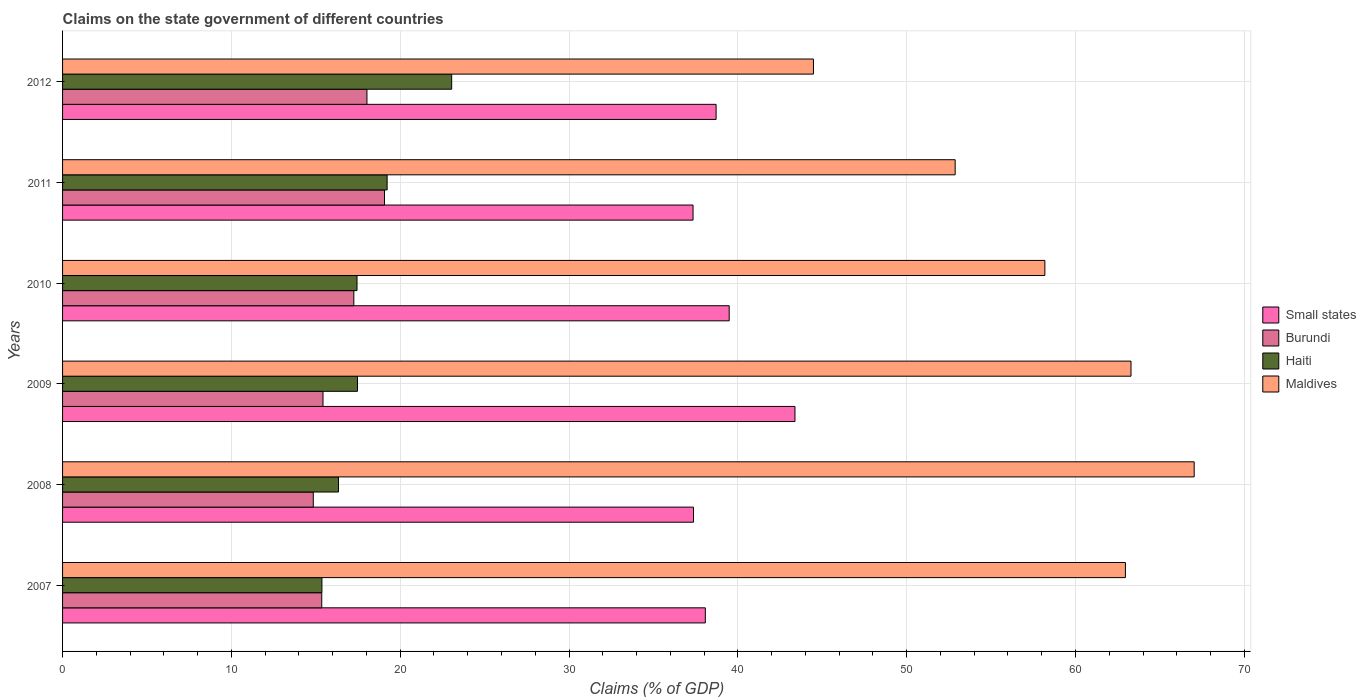How many groups of bars are there?
Provide a short and direct response. 6. Are the number of bars per tick equal to the number of legend labels?
Your response must be concise. Yes. Are the number of bars on each tick of the Y-axis equal?
Provide a succinct answer. Yes. How many bars are there on the 4th tick from the top?
Give a very brief answer. 4. What is the label of the 2nd group of bars from the top?
Give a very brief answer. 2011. In how many cases, is the number of bars for a given year not equal to the number of legend labels?
Make the answer very short. 0. What is the percentage of GDP claimed on the state government in Burundi in 2010?
Offer a very short reply. 17.25. Across all years, what is the maximum percentage of GDP claimed on the state government in Haiti?
Offer a terse response. 23.05. Across all years, what is the minimum percentage of GDP claimed on the state government in Small states?
Keep it short and to the point. 37.35. In which year was the percentage of GDP claimed on the state government in Burundi maximum?
Your answer should be compact. 2011. In which year was the percentage of GDP claimed on the state government in Haiti minimum?
Offer a terse response. 2007. What is the total percentage of GDP claimed on the state government in Burundi in the graph?
Your answer should be very brief. 99.98. What is the difference between the percentage of GDP claimed on the state government in Maldives in 2009 and that in 2012?
Your response must be concise. 18.81. What is the difference between the percentage of GDP claimed on the state government in Small states in 2009 and the percentage of GDP claimed on the state government in Burundi in 2012?
Your answer should be compact. 25.35. What is the average percentage of GDP claimed on the state government in Haiti per year?
Your answer should be very brief. 18.15. In the year 2010, what is the difference between the percentage of GDP claimed on the state government in Burundi and percentage of GDP claimed on the state government in Small states?
Provide a short and direct response. -22.24. What is the ratio of the percentage of GDP claimed on the state government in Haiti in 2008 to that in 2012?
Make the answer very short. 0.71. Is the difference between the percentage of GDP claimed on the state government in Burundi in 2007 and 2009 greater than the difference between the percentage of GDP claimed on the state government in Small states in 2007 and 2009?
Offer a very short reply. Yes. What is the difference between the highest and the second highest percentage of GDP claimed on the state government in Maldives?
Your answer should be compact. 3.74. What is the difference between the highest and the lowest percentage of GDP claimed on the state government in Maldives?
Offer a very short reply. 22.55. Is the sum of the percentage of GDP claimed on the state government in Maldives in 2007 and 2010 greater than the maximum percentage of GDP claimed on the state government in Haiti across all years?
Offer a very short reply. Yes. What does the 4th bar from the top in 2007 represents?
Offer a terse response. Small states. What does the 1st bar from the bottom in 2009 represents?
Offer a terse response. Small states. Are all the bars in the graph horizontal?
Provide a short and direct response. Yes. How many years are there in the graph?
Offer a terse response. 6. Are the values on the major ticks of X-axis written in scientific E-notation?
Offer a terse response. No. Does the graph contain any zero values?
Keep it short and to the point. No. Does the graph contain grids?
Offer a very short reply. Yes. Where does the legend appear in the graph?
Your answer should be very brief. Center right. How many legend labels are there?
Your answer should be compact. 4. What is the title of the graph?
Give a very brief answer. Claims on the state government of different countries. Does "Arab World" appear as one of the legend labels in the graph?
Give a very brief answer. No. What is the label or title of the X-axis?
Provide a succinct answer. Claims (% of GDP). What is the label or title of the Y-axis?
Provide a short and direct response. Years. What is the Claims (% of GDP) in Small states in 2007?
Your response must be concise. 38.07. What is the Claims (% of GDP) of Burundi in 2007?
Give a very brief answer. 15.35. What is the Claims (% of GDP) of Haiti in 2007?
Ensure brevity in your answer.  15.36. What is the Claims (% of GDP) of Maldives in 2007?
Ensure brevity in your answer.  62.96. What is the Claims (% of GDP) in Small states in 2008?
Ensure brevity in your answer.  37.37. What is the Claims (% of GDP) in Burundi in 2008?
Your answer should be compact. 14.85. What is the Claims (% of GDP) in Haiti in 2008?
Your response must be concise. 16.34. What is the Claims (% of GDP) in Maldives in 2008?
Provide a short and direct response. 67.03. What is the Claims (% of GDP) in Small states in 2009?
Provide a succinct answer. 43.38. What is the Claims (% of GDP) of Burundi in 2009?
Provide a succinct answer. 15.43. What is the Claims (% of GDP) in Haiti in 2009?
Your answer should be compact. 17.47. What is the Claims (% of GDP) in Maldives in 2009?
Make the answer very short. 63.29. What is the Claims (% of GDP) of Small states in 2010?
Provide a short and direct response. 39.49. What is the Claims (% of GDP) of Burundi in 2010?
Provide a succinct answer. 17.25. What is the Claims (% of GDP) in Haiti in 2010?
Ensure brevity in your answer.  17.44. What is the Claims (% of GDP) in Maldives in 2010?
Provide a short and direct response. 58.19. What is the Claims (% of GDP) of Small states in 2011?
Keep it short and to the point. 37.35. What is the Claims (% of GDP) of Burundi in 2011?
Your response must be concise. 19.07. What is the Claims (% of GDP) of Haiti in 2011?
Offer a very short reply. 19.23. What is the Claims (% of GDP) of Maldives in 2011?
Offer a very short reply. 52.87. What is the Claims (% of GDP) of Small states in 2012?
Your answer should be compact. 38.71. What is the Claims (% of GDP) in Burundi in 2012?
Your answer should be compact. 18.03. What is the Claims (% of GDP) in Haiti in 2012?
Keep it short and to the point. 23.05. What is the Claims (% of GDP) of Maldives in 2012?
Give a very brief answer. 44.48. Across all years, what is the maximum Claims (% of GDP) in Small states?
Provide a short and direct response. 43.38. Across all years, what is the maximum Claims (% of GDP) of Burundi?
Your answer should be compact. 19.07. Across all years, what is the maximum Claims (% of GDP) of Haiti?
Offer a very short reply. 23.05. Across all years, what is the maximum Claims (% of GDP) of Maldives?
Provide a succinct answer. 67.03. Across all years, what is the minimum Claims (% of GDP) in Small states?
Ensure brevity in your answer.  37.35. Across all years, what is the minimum Claims (% of GDP) in Burundi?
Offer a very short reply. 14.85. Across all years, what is the minimum Claims (% of GDP) in Haiti?
Ensure brevity in your answer.  15.36. Across all years, what is the minimum Claims (% of GDP) in Maldives?
Give a very brief answer. 44.48. What is the total Claims (% of GDP) in Small states in the graph?
Make the answer very short. 234.38. What is the total Claims (% of GDP) of Burundi in the graph?
Ensure brevity in your answer.  99.98. What is the total Claims (% of GDP) in Haiti in the graph?
Provide a succinct answer. 108.89. What is the total Claims (% of GDP) of Maldives in the graph?
Your response must be concise. 348.82. What is the difference between the Claims (% of GDP) in Small states in 2007 and that in 2008?
Offer a very short reply. 0.7. What is the difference between the Claims (% of GDP) of Burundi in 2007 and that in 2008?
Offer a terse response. 0.5. What is the difference between the Claims (% of GDP) of Haiti in 2007 and that in 2008?
Offer a very short reply. -0.98. What is the difference between the Claims (% of GDP) of Maldives in 2007 and that in 2008?
Provide a succinct answer. -4.07. What is the difference between the Claims (% of GDP) in Small states in 2007 and that in 2009?
Ensure brevity in your answer.  -5.31. What is the difference between the Claims (% of GDP) in Burundi in 2007 and that in 2009?
Give a very brief answer. -0.07. What is the difference between the Claims (% of GDP) of Haiti in 2007 and that in 2009?
Offer a very short reply. -2.11. What is the difference between the Claims (% of GDP) in Maldives in 2007 and that in 2009?
Your answer should be very brief. -0.33. What is the difference between the Claims (% of GDP) of Small states in 2007 and that in 2010?
Offer a terse response. -1.41. What is the difference between the Claims (% of GDP) in Burundi in 2007 and that in 2010?
Your answer should be compact. -1.9. What is the difference between the Claims (% of GDP) of Haiti in 2007 and that in 2010?
Give a very brief answer. -2.08. What is the difference between the Claims (% of GDP) of Maldives in 2007 and that in 2010?
Your answer should be compact. 4.77. What is the difference between the Claims (% of GDP) in Small states in 2007 and that in 2011?
Give a very brief answer. 0.73. What is the difference between the Claims (% of GDP) in Burundi in 2007 and that in 2011?
Keep it short and to the point. -3.72. What is the difference between the Claims (% of GDP) of Haiti in 2007 and that in 2011?
Keep it short and to the point. -3.86. What is the difference between the Claims (% of GDP) of Maldives in 2007 and that in 2011?
Keep it short and to the point. 10.08. What is the difference between the Claims (% of GDP) of Small states in 2007 and that in 2012?
Offer a very short reply. -0.64. What is the difference between the Claims (% of GDP) in Burundi in 2007 and that in 2012?
Provide a short and direct response. -2.68. What is the difference between the Claims (% of GDP) in Haiti in 2007 and that in 2012?
Offer a terse response. -7.69. What is the difference between the Claims (% of GDP) in Maldives in 2007 and that in 2012?
Offer a terse response. 18.48. What is the difference between the Claims (% of GDP) in Small states in 2008 and that in 2009?
Provide a short and direct response. -6.01. What is the difference between the Claims (% of GDP) in Burundi in 2008 and that in 2009?
Offer a terse response. -0.58. What is the difference between the Claims (% of GDP) in Haiti in 2008 and that in 2009?
Offer a terse response. -1.13. What is the difference between the Claims (% of GDP) of Maldives in 2008 and that in 2009?
Your answer should be compact. 3.74. What is the difference between the Claims (% of GDP) of Small states in 2008 and that in 2010?
Your answer should be very brief. -2.12. What is the difference between the Claims (% of GDP) in Burundi in 2008 and that in 2010?
Your answer should be very brief. -2.4. What is the difference between the Claims (% of GDP) in Haiti in 2008 and that in 2010?
Ensure brevity in your answer.  -1.1. What is the difference between the Claims (% of GDP) of Maldives in 2008 and that in 2010?
Ensure brevity in your answer.  8.84. What is the difference between the Claims (% of GDP) of Small states in 2008 and that in 2011?
Your answer should be very brief. 0.03. What is the difference between the Claims (% of GDP) in Burundi in 2008 and that in 2011?
Keep it short and to the point. -4.22. What is the difference between the Claims (% of GDP) in Haiti in 2008 and that in 2011?
Provide a short and direct response. -2.88. What is the difference between the Claims (% of GDP) in Maldives in 2008 and that in 2011?
Keep it short and to the point. 14.16. What is the difference between the Claims (% of GDP) of Small states in 2008 and that in 2012?
Keep it short and to the point. -1.34. What is the difference between the Claims (% of GDP) in Burundi in 2008 and that in 2012?
Make the answer very short. -3.18. What is the difference between the Claims (% of GDP) in Haiti in 2008 and that in 2012?
Make the answer very short. -6.7. What is the difference between the Claims (% of GDP) in Maldives in 2008 and that in 2012?
Give a very brief answer. 22.55. What is the difference between the Claims (% of GDP) in Small states in 2009 and that in 2010?
Your response must be concise. 3.9. What is the difference between the Claims (% of GDP) of Burundi in 2009 and that in 2010?
Your answer should be very brief. -1.83. What is the difference between the Claims (% of GDP) in Haiti in 2009 and that in 2010?
Give a very brief answer. 0.03. What is the difference between the Claims (% of GDP) in Maldives in 2009 and that in 2010?
Provide a short and direct response. 5.1. What is the difference between the Claims (% of GDP) in Small states in 2009 and that in 2011?
Keep it short and to the point. 6.04. What is the difference between the Claims (% of GDP) of Burundi in 2009 and that in 2011?
Your answer should be compact. -3.64. What is the difference between the Claims (% of GDP) in Haiti in 2009 and that in 2011?
Your answer should be very brief. -1.76. What is the difference between the Claims (% of GDP) of Maldives in 2009 and that in 2011?
Your answer should be compact. 10.42. What is the difference between the Claims (% of GDP) of Small states in 2009 and that in 2012?
Offer a terse response. 4.67. What is the difference between the Claims (% of GDP) in Burundi in 2009 and that in 2012?
Offer a terse response. -2.6. What is the difference between the Claims (% of GDP) of Haiti in 2009 and that in 2012?
Offer a very short reply. -5.58. What is the difference between the Claims (% of GDP) in Maldives in 2009 and that in 2012?
Offer a very short reply. 18.81. What is the difference between the Claims (% of GDP) of Small states in 2010 and that in 2011?
Your answer should be very brief. 2.14. What is the difference between the Claims (% of GDP) of Burundi in 2010 and that in 2011?
Ensure brevity in your answer.  -1.82. What is the difference between the Claims (% of GDP) of Haiti in 2010 and that in 2011?
Provide a short and direct response. -1.78. What is the difference between the Claims (% of GDP) of Maldives in 2010 and that in 2011?
Ensure brevity in your answer.  5.31. What is the difference between the Claims (% of GDP) in Small states in 2010 and that in 2012?
Offer a terse response. 0.78. What is the difference between the Claims (% of GDP) of Burundi in 2010 and that in 2012?
Provide a short and direct response. -0.78. What is the difference between the Claims (% of GDP) in Haiti in 2010 and that in 2012?
Your answer should be very brief. -5.61. What is the difference between the Claims (% of GDP) of Maldives in 2010 and that in 2012?
Make the answer very short. 13.71. What is the difference between the Claims (% of GDP) of Small states in 2011 and that in 2012?
Make the answer very short. -1.37. What is the difference between the Claims (% of GDP) in Burundi in 2011 and that in 2012?
Offer a terse response. 1.04. What is the difference between the Claims (% of GDP) in Haiti in 2011 and that in 2012?
Give a very brief answer. -3.82. What is the difference between the Claims (% of GDP) of Maldives in 2011 and that in 2012?
Your answer should be very brief. 8.39. What is the difference between the Claims (% of GDP) of Small states in 2007 and the Claims (% of GDP) of Burundi in 2008?
Your answer should be very brief. 23.22. What is the difference between the Claims (% of GDP) of Small states in 2007 and the Claims (% of GDP) of Haiti in 2008?
Offer a terse response. 21.73. What is the difference between the Claims (% of GDP) in Small states in 2007 and the Claims (% of GDP) in Maldives in 2008?
Keep it short and to the point. -28.96. What is the difference between the Claims (% of GDP) in Burundi in 2007 and the Claims (% of GDP) in Haiti in 2008?
Offer a terse response. -0.99. What is the difference between the Claims (% of GDP) of Burundi in 2007 and the Claims (% of GDP) of Maldives in 2008?
Provide a short and direct response. -51.68. What is the difference between the Claims (% of GDP) in Haiti in 2007 and the Claims (% of GDP) in Maldives in 2008?
Make the answer very short. -51.67. What is the difference between the Claims (% of GDP) in Small states in 2007 and the Claims (% of GDP) in Burundi in 2009?
Give a very brief answer. 22.65. What is the difference between the Claims (% of GDP) in Small states in 2007 and the Claims (% of GDP) in Haiti in 2009?
Your answer should be compact. 20.6. What is the difference between the Claims (% of GDP) of Small states in 2007 and the Claims (% of GDP) of Maldives in 2009?
Provide a succinct answer. -25.22. What is the difference between the Claims (% of GDP) of Burundi in 2007 and the Claims (% of GDP) of Haiti in 2009?
Ensure brevity in your answer.  -2.12. What is the difference between the Claims (% of GDP) of Burundi in 2007 and the Claims (% of GDP) of Maldives in 2009?
Offer a terse response. -47.94. What is the difference between the Claims (% of GDP) of Haiti in 2007 and the Claims (% of GDP) of Maldives in 2009?
Offer a very short reply. -47.93. What is the difference between the Claims (% of GDP) of Small states in 2007 and the Claims (% of GDP) of Burundi in 2010?
Provide a succinct answer. 20.82. What is the difference between the Claims (% of GDP) of Small states in 2007 and the Claims (% of GDP) of Haiti in 2010?
Make the answer very short. 20.63. What is the difference between the Claims (% of GDP) of Small states in 2007 and the Claims (% of GDP) of Maldives in 2010?
Provide a short and direct response. -20.11. What is the difference between the Claims (% of GDP) in Burundi in 2007 and the Claims (% of GDP) in Haiti in 2010?
Your response must be concise. -2.09. What is the difference between the Claims (% of GDP) of Burundi in 2007 and the Claims (% of GDP) of Maldives in 2010?
Make the answer very short. -42.83. What is the difference between the Claims (% of GDP) of Haiti in 2007 and the Claims (% of GDP) of Maldives in 2010?
Offer a terse response. -42.82. What is the difference between the Claims (% of GDP) of Small states in 2007 and the Claims (% of GDP) of Burundi in 2011?
Give a very brief answer. 19. What is the difference between the Claims (% of GDP) in Small states in 2007 and the Claims (% of GDP) in Haiti in 2011?
Your answer should be very brief. 18.85. What is the difference between the Claims (% of GDP) in Small states in 2007 and the Claims (% of GDP) in Maldives in 2011?
Your answer should be compact. -14.8. What is the difference between the Claims (% of GDP) in Burundi in 2007 and the Claims (% of GDP) in Haiti in 2011?
Your response must be concise. -3.87. What is the difference between the Claims (% of GDP) in Burundi in 2007 and the Claims (% of GDP) in Maldives in 2011?
Your response must be concise. -37.52. What is the difference between the Claims (% of GDP) in Haiti in 2007 and the Claims (% of GDP) in Maldives in 2011?
Keep it short and to the point. -37.51. What is the difference between the Claims (% of GDP) in Small states in 2007 and the Claims (% of GDP) in Burundi in 2012?
Your answer should be compact. 20.04. What is the difference between the Claims (% of GDP) of Small states in 2007 and the Claims (% of GDP) of Haiti in 2012?
Provide a short and direct response. 15.03. What is the difference between the Claims (% of GDP) of Small states in 2007 and the Claims (% of GDP) of Maldives in 2012?
Your answer should be compact. -6.41. What is the difference between the Claims (% of GDP) of Burundi in 2007 and the Claims (% of GDP) of Haiti in 2012?
Your answer should be very brief. -7.7. What is the difference between the Claims (% of GDP) of Burundi in 2007 and the Claims (% of GDP) of Maldives in 2012?
Provide a succinct answer. -29.13. What is the difference between the Claims (% of GDP) of Haiti in 2007 and the Claims (% of GDP) of Maldives in 2012?
Give a very brief answer. -29.12. What is the difference between the Claims (% of GDP) in Small states in 2008 and the Claims (% of GDP) in Burundi in 2009?
Offer a very short reply. 21.95. What is the difference between the Claims (% of GDP) of Small states in 2008 and the Claims (% of GDP) of Haiti in 2009?
Offer a terse response. 19.9. What is the difference between the Claims (% of GDP) in Small states in 2008 and the Claims (% of GDP) in Maldives in 2009?
Your answer should be compact. -25.92. What is the difference between the Claims (% of GDP) of Burundi in 2008 and the Claims (% of GDP) of Haiti in 2009?
Ensure brevity in your answer.  -2.62. What is the difference between the Claims (% of GDP) of Burundi in 2008 and the Claims (% of GDP) of Maldives in 2009?
Provide a short and direct response. -48.44. What is the difference between the Claims (% of GDP) in Haiti in 2008 and the Claims (% of GDP) in Maldives in 2009?
Your answer should be very brief. -46.94. What is the difference between the Claims (% of GDP) in Small states in 2008 and the Claims (% of GDP) in Burundi in 2010?
Your answer should be very brief. 20.12. What is the difference between the Claims (% of GDP) in Small states in 2008 and the Claims (% of GDP) in Haiti in 2010?
Give a very brief answer. 19.93. What is the difference between the Claims (% of GDP) of Small states in 2008 and the Claims (% of GDP) of Maldives in 2010?
Give a very brief answer. -20.81. What is the difference between the Claims (% of GDP) of Burundi in 2008 and the Claims (% of GDP) of Haiti in 2010?
Your answer should be very brief. -2.59. What is the difference between the Claims (% of GDP) in Burundi in 2008 and the Claims (% of GDP) in Maldives in 2010?
Provide a succinct answer. -43.34. What is the difference between the Claims (% of GDP) in Haiti in 2008 and the Claims (% of GDP) in Maldives in 2010?
Your answer should be compact. -41.84. What is the difference between the Claims (% of GDP) of Small states in 2008 and the Claims (% of GDP) of Burundi in 2011?
Keep it short and to the point. 18.3. What is the difference between the Claims (% of GDP) in Small states in 2008 and the Claims (% of GDP) in Haiti in 2011?
Provide a succinct answer. 18.15. What is the difference between the Claims (% of GDP) of Small states in 2008 and the Claims (% of GDP) of Maldives in 2011?
Your answer should be compact. -15.5. What is the difference between the Claims (% of GDP) in Burundi in 2008 and the Claims (% of GDP) in Haiti in 2011?
Make the answer very short. -4.37. What is the difference between the Claims (% of GDP) of Burundi in 2008 and the Claims (% of GDP) of Maldives in 2011?
Offer a very short reply. -38.02. What is the difference between the Claims (% of GDP) of Haiti in 2008 and the Claims (% of GDP) of Maldives in 2011?
Your answer should be very brief. -36.53. What is the difference between the Claims (% of GDP) of Small states in 2008 and the Claims (% of GDP) of Burundi in 2012?
Provide a short and direct response. 19.34. What is the difference between the Claims (% of GDP) in Small states in 2008 and the Claims (% of GDP) in Haiti in 2012?
Make the answer very short. 14.32. What is the difference between the Claims (% of GDP) in Small states in 2008 and the Claims (% of GDP) in Maldives in 2012?
Your answer should be compact. -7.11. What is the difference between the Claims (% of GDP) in Burundi in 2008 and the Claims (% of GDP) in Haiti in 2012?
Offer a very short reply. -8.2. What is the difference between the Claims (% of GDP) in Burundi in 2008 and the Claims (% of GDP) in Maldives in 2012?
Give a very brief answer. -29.63. What is the difference between the Claims (% of GDP) of Haiti in 2008 and the Claims (% of GDP) of Maldives in 2012?
Your answer should be compact. -28.13. What is the difference between the Claims (% of GDP) of Small states in 2009 and the Claims (% of GDP) of Burundi in 2010?
Offer a very short reply. 26.13. What is the difference between the Claims (% of GDP) in Small states in 2009 and the Claims (% of GDP) in Haiti in 2010?
Provide a short and direct response. 25.94. What is the difference between the Claims (% of GDP) of Small states in 2009 and the Claims (% of GDP) of Maldives in 2010?
Your response must be concise. -14.8. What is the difference between the Claims (% of GDP) of Burundi in 2009 and the Claims (% of GDP) of Haiti in 2010?
Your response must be concise. -2.01. What is the difference between the Claims (% of GDP) in Burundi in 2009 and the Claims (% of GDP) in Maldives in 2010?
Provide a succinct answer. -42.76. What is the difference between the Claims (% of GDP) in Haiti in 2009 and the Claims (% of GDP) in Maldives in 2010?
Provide a succinct answer. -40.72. What is the difference between the Claims (% of GDP) in Small states in 2009 and the Claims (% of GDP) in Burundi in 2011?
Provide a short and direct response. 24.31. What is the difference between the Claims (% of GDP) in Small states in 2009 and the Claims (% of GDP) in Haiti in 2011?
Offer a terse response. 24.16. What is the difference between the Claims (% of GDP) in Small states in 2009 and the Claims (% of GDP) in Maldives in 2011?
Give a very brief answer. -9.49. What is the difference between the Claims (% of GDP) of Burundi in 2009 and the Claims (% of GDP) of Haiti in 2011?
Provide a short and direct response. -3.8. What is the difference between the Claims (% of GDP) of Burundi in 2009 and the Claims (% of GDP) of Maldives in 2011?
Make the answer very short. -37.45. What is the difference between the Claims (% of GDP) of Haiti in 2009 and the Claims (% of GDP) of Maldives in 2011?
Ensure brevity in your answer.  -35.4. What is the difference between the Claims (% of GDP) of Small states in 2009 and the Claims (% of GDP) of Burundi in 2012?
Your answer should be very brief. 25.35. What is the difference between the Claims (% of GDP) in Small states in 2009 and the Claims (% of GDP) in Haiti in 2012?
Give a very brief answer. 20.34. What is the difference between the Claims (% of GDP) of Small states in 2009 and the Claims (% of GDP) of Maldives in 2012?
Offer a very short reply. -1.1. What is the difference between the Claims (% of GDP) in Burundi in 2009 and the Claims (% of GDP) in Haiti in 2012?
Make the answer very short. -7.62. What is the difference between the Claims (% of GDP) of Burundi in 2009 and the Claims (% of GDP) of Maldives in 2012?
Make the answer very short. -29.05. What is the difference between the Claims (% of GDP) of Haiti in 2009 and the Claims (% of GDP) of Maldives in 2012?
Provide a short and direct response. -27.01. What is the difference between the Claims (% of GDP) of Small states in 2010 and the Claims (% of GDP) of Burundi in 2011?
Offer a terse response. 20.42. What is the difference between the Claims (% of GDP) in Small states in 2010 and the Claims (% of GDP) in Haiti in 2011?
Your response must be concise. 20.26. What is the difference between the Claims (% of GDP) of Small states in 2010 and the Claims (% of GDP) of Maldives in 2011?
Your response must be concise. -13.39. What is the difference between the Claims (% of GDP) in Burundi in 2010 and the Claims (% of GDP) in Haiti in 2011?
Your answer should be compact. -1.97. What is the difference between the Claims (% of GDP) in Burundi in 2010 and the Claims (% of GDP) in Maldives in 2011?
Give a very brief answer. -35.62. What is the difference between the Claims (% of GDP) in Haiti in 2010 and the Claims (% of GDP) in Maldives in 2011?
Your answer should be compact. -35.43. What is the difference between the Claims (% of GDP) of Small states in 2010 and the Claims (% of GDP) of Burundi in 2012?
Offer a very short reply. 21.46. What is the difference between the Claims (% of GDP) of Small states in 2010 and the Claims (% of GDP) of Haiti in 2012?
Your answer should be very brief. 16.44. What is the difference between the Claims (% of GDP) of Small states in 2010 and the Claims (% of GDP) of Maldives in 2012?
Ensure brevity in your answer.  -4.99. What is the difference between the Claims (% of GDP) in Burundi in 2010 and the Claims (% of GDP) in Haiti in 2012?
Your answer should be very brief. -5.8. What is the difference between the Claims (% of GDP) in Burundi in 2010 and the Claims (% of GDP) in Maldives in 2012?
Your answer should be very brief. -27.23. What is the difference between the Claims (% of GDP) of Haiti in 2010 and the Claims (% of GDP) of Maldives in 2012?
Ensure brevity in your answer.  -27.04. What is the difference between the Claims (% of GDP) in Small states in 2011 and the Claims (% of GDP) in Burundi in 2012?
Your answer should be compact. 19.32. What is the difference between the Claims (% of GDP) in Small states in 2011 and the Claims (% of GDP) in Haiti in 2012?
Make the answer very short. 14.3. What is the difference between the Claims (% of GDP) of Small states in 2011 and the Claims (% of GDP) of Maldives in 2012?
Keep it short and to the point. -7.13. What is the difference between the Claims (% of GDP) in Burundi in 2011 and the Claims (% of GDP) in Haiti in 2012?
Make the answer very short. -3.98. What is the difference between the Claims (% of GDP) in Burundi in 2011 and the Claims (% of GDP) in Maldives in 2012?
Your response must be concise. -25.41. What is the difference between the Claims (% of GDP) of Haiti in 2011 and the Claims (% of GDP) of Maldives in 2012?
Your response must be concise. -25.25. What is the average Claims (% of GDP) of Small states per year?
Your answer should be compact. 39.06. What is the average Claims (% of GDP) of Burundi per year?
Provide a short and direct response. 16.66. What is the average Claims (% of GDP) in Haiti per year?
Keep it short and to the point. 18.15. What is the average Claims (% of GDP) of Maldives per year?
Offer a very short reply. 58.14. In the year 2007, what is the difference between the Claims (% of GDP) of Small states and Claims (% of GDP) of Burundi?
Provide a succinct answer. 22.72. In the year 2007, what is the difference between the Claims (% of GDP) of Small states and Claims (% of GDP) of Haiti?
Keep it short and to the point. 22.71. In the year 2007, what is the difference between the Claims (% of GDP) in Small states and Claims (% of GDP) in Maldives?
Ensure brevity in your answer.  -24.88. In the year 2007, what is the difference between the Claims (% of GDP) of Burundi and Claims (% of GDP) of Haiti?
Provide a short and direct response. -0.01. In the year 2007, what is the difference between the Claims (% of GDP) of Burundi and Claims (% of GDP) of Maldives?
Give a very brief answer. -47.61. In the year 2007, what is the difference between the Claims (% of GDP) of Haiti and Claims (% of GDP) of Maldives?
Ensure brevity in your answer.  -47.59. In the year 2008, what is the difference between the Claims (% of GDP) of Small states and Claims (% of GDP) of Burundi?
Give a very brief answer. 22.52. In the year 2008, what is the difference between the Claims (% of GDP) in Small states and Claims (% of GDP) in Haiti?
Provide a succinct answer. 21.03. In the year 2008, what is the difference between the Claims (% of GDP) of Small states and Claims (% of GDP) of Maldives?
Make the answer very short. -29.66. In the year 2008, what is the difference between the Claims (% of GDP) in Burundi and Claims (% of GDP) in Haiti?
Offer a very short reply. -1.49. In the year 2008, what is the difference between the Claims (% of GDP) of Burundi and Claims (% of GDP) of Maldives?
Keep it short and to the point. -52.18. In the year 2008, what is the difference between the Claims (% of GDP) of Haiti and Claims (% of GDP) of Maldives?
Ensure brevity in your answer.  -50.69. In the year 2009, what is the difference between the Claims (% of GDP) of Small states and Claims (% of GDP) of Burundi?
Your answer should be compact. 27.96. In the year 2009, what is the difference between the Claims (% of GDP) of Small states and Claims (% of GDP) of Haiti?
Provide a succinct answer. 25.91. In the year 2009, what is the difference between the Claims (% of GDP) of Small states and Claims (% of GDP) of Maldives?
Make the answer very short. -19.91. In the year 2009, what is the difference between the Claims (% of GDP) in Burundi and Claims (% of GDP) in Haiti?
Provide a short and direct response. -2.04. In the year 2009, what is the difference between the Claims (% of GDP) in Burundi and Claims (% of GDP) in Maldives?
Ensure brevity in your answer.  -47.86. In the year 2009, what is the difference between the Claims (% of GDP) of Haiti and Claims (% of GDP) of Maldives?
Ensure brevity in your answer.  -45.82. In the year 2010, what is the difference between the Claims (% of GDP) of Small states and Claims (% of GDP) of Burundi?
Provide a short and direct response. 22.24. In the year 2010, what is the difference between the Claims (% of GDP) in Small states and Claims (% of GDP) in Haiti?
Provide a succinct answer. 22.05. In the year 2010, what is the difference between the Claims (% of GDP) of Small states and Claims (% of GDP) of Maldives?
Your answer should be very brief. -18.7. In the year 2010, what is the difference between the Claims (% of GDP) of Burundi and Claims (% of GDP) of Haiti?
Ensure brevity in your answer.  -0.19. In the year 2010, what is the difference between the Claims (% of GDP) in Burundi and Claims (% of GDP) in Maldives?
Your response must be concise. -40.93. In the year 2010, what is the difference between the Claims (% of GDP) of Haiti and Claims (% of GDP) of Maldives?
Give a very brief answer. -40.75. In the year 2011, what is the difference between the Claims (% of GDP) of Small states and Claims (% of GDP) of Burundi?
Your response must be concise. 18.28. In the year 2011, what is the difference between the Claims (% of GDP) of Small states and Claims (% of GDP) of Haiti?
Make the answer very short. 18.12. In the year 2011, what is the difference between the Claims (% of GDP) of Small states and Claims (% of GDP) of Maldives?
Provide a succinct answer. -15.53. In the year 2011, what is the difference between the Claims (% of GDP) in Burundi and Claims (% of GDP) in Haiti?
Provide a succinct answer. -0.16. In the year 2011, what is the difference between the Claims (% of GDP) of Burundi and Claims (% of GDP) of Maldives?
Ensure brevity in your answer.  -33.8. In the year 2011, what is the difference between the Claims (% of GDP) in Haiti and Claims (% of GDP) in Maldives?
Provide a short and direct response. -33.65. In the year 2012, what is the difference between the Claims (% of GDP) of Small states and Claims (% of GDP) of Burundi?
Provide a short and direct response. 20.68. In the year 2012, what is the difference between the Claims (% of GDP) in Small states and Claims (% of GDP) in Haiti?
Your response must be concise. 15.66. In the year 2012, what is the difference between the Claims (% of GDP) of Small states and Claims (% of GDP) of Maldives?
Ensure brevity in your answer.  -5.77. In the year 2012, what is the difference between the Claims (% of GDP) in Burundi and Claims (% of GDP) in Haiti?
Make the answer very short. -5.02. In the year 2012, what is the difference between the Claims (% of GDP) of Burundi and Claims (% of GDP) of Maldives?
Your answer should be compact. -26.45. In the year 2012, what is the difference between the Claims (% of GDP) in Haiti and Claims (% of GDP) in Maldives?
Keep it short and to the point. -21.43. What is the ratio of the Claims (% of GDP) in Small states in 2007 to that in 2008?
Give a very brief answer. 1.02. What is the ratio of the Claims (% of GDP) in Burundi in 2007 to that in 2008?
Offer a very short reply. 1.03. What is the ratio of the Claims (% of GDP) of Haiti in 2007 to that in 2008?
Provide a succinct answer. 0.94. What is the ratio of the Claims (% of GDP) of Maldives in 2007 to that in 2008?
Keep it short and to the point. 0.94. What is the ratio of the Claims (% of GDP) of Small states in 2007 to that in 2009?
Keep it short and to the point. 0.88. What is the ratio of the Claims (% of GDP) of Haiti in 2007 to that in 2009?
Make the answer very short. 0.88. What is the ratio of the Claims (% of GDP) of Maldives in 2007 to that in 2009?
Offer a very short reply. 0.99. What is the ratio of the Claims (% of GDP) in Small states in 2007 to that in 2010?
Ensure brevity in your answer.  0.96. What is the ratio of the Claims (% of GDP) of Burundi in 2007 to that in 2010?
Give a very brief answer. 0.89. What is the ratio of the Claims (% of GDP) in Haiti in 2007 to that in 2010?
Provide a succinct answer. 0.88. What is the ratio of the Claims (% of GDP) in Maldives in 2007 to that in 2010?
Ensure brevity in your answer.  1.08. What is the ratio of the Claims (% of GDP) of Small states in 2007 to that in 2011?
Keep it short and to the point. 1.02. What is the ratio of the Claims (% of GDP) in Burundi in 2007 to that in 2011?
Offer a very short reply. 0.81. What is the ratio of the Claims (% of GDP) of Haiti in 2007 to that in 2011?
Your response must be concise. 0.8. What is the ratio of the Claims (% of GDP) in Maldives in 2007 to that in 2011?
Offer a terse response. 1.19. What is the ratio of the Claims (% of GDP) in Small states in 2007 to that in 2012?
Provide a short and direct response. 0.98. What is the ratio of the Claims (% of GDP) in Burundi in 2007 to that in 2012?
Offer a very short reply. 0.85. What is the ratio of the Claims (% of GDP) of Haiti in 2007 to that in 2012?
Offer a very short reply. 0.67. What is the ratio of the Claims (% of GDP) of Maldives in 2007 to that in 2012?
Provide a succinct answer. 1.42. What is the ratio of the Claims (% of GDP) of Small states in 2008 to that in 2009?
Your answer should be compact. 0.86. What is the ratio of the Claims (% of GDP) of Burundi in 2008 to that in 2009?
Provide a succinct answer. 0.96. What is the ratio of the Claims (% of GDP) of Haiti in 2008 to that in 2009?
Make the answer very short. 0.94. What is the ratio of the Claims (% of GDP) in Maldives in 2008 to that in 2009?
Offer a terse response. 1.06. What is the ratio of the Claims (% of GDP) in Small states in 2008 to that in 2010?
Give a very brief answer. 0.95. What is the ratio of the Claims (% of GDP) in Burundi in 2008 to that in 2010?
Give a very brief answer. 0.86. What is the ratio of the Claims (% of GDP) of Haiti in 2008 to that in 2010?
Your answer should be compact. 0.94. What is the ratio of the Claims (% of GDP) of Maldives in 2008 to that in 2010?
Provide a short and direct response. 1.15. What is the ratio of the Claims (% of GDP) of Burundi in 2008 to that in 2011?
Ensure brevity in your answer.  0.78. What is the ratio of the Claims (% of GDP) in Haiti in 2008 to that in 2011?
Your answer should be very brief. 0.85. What is the ratio of the Claims (% of GDP) in Maldives in 2008 to that in 2011?
Your response must be concise. 1.27. What is the ratio of the Claims (% of GDP) in Small states in 2008 to that in 2012?
Your answer should be very brief. 0.97. What is the ratio of the Claims (% of GDP) of Burundi in 2008 to that in 2012?
Offer a very short reply. 0.82. What is the ratio of the Claims (% of GDP) in Haiti in 2008 to that in 2012?
Ensure brevity in your answer.  0.71. What is the ratio of the Claims (% of GDP) of Maldives in 2008 to that in 2012?
Provide a succinct answer. 1.51. What is the ratio of the Claims (% of GDP) of Small states in 2009 to that in 2010?
Ensure brevity in your answer.  1.1. What is the ratio of the Claims (% of GDP) in Burundi in 2009 to that in 2010?
Your answer should be very brief. 0.89. What is the ratio of the Claims (% of GDP) in Maldives in 2009 to that in 2010?
Your answer should be very brief. 1.09. What is the ratio of the Claims (% of GDP) in Small states in 2009 to that in 2011?
Your response must be concise. 1.16. What is the ratio of the Claims (% of GDP) in Burundi in 2009 to that in 2011?
Ensure brevity in your answer.  0.81. What is the ratio of the Claims (% of GDP) of Haiti in 2009 to that in 2011?
Your answer should be very brief. 0.91. What is the ratio of the Claims (% of GDP) in Maldives in 2009 to that in 2011?
Ensure brevity in your answer.  1.2. What is the ratio of the Claims (% of GDP) of Small states in 2009 to that in 2012?
Provide a succinct answer. 1.12. What is the ratio of the Claims (% of GDP) of Burundi in 2009 to that in 2012?
Provide a short and direct response. 0.86. What is the ratio of the Claims (% of GDP) of Haiti in 2009 to that in 2012?
Your response must be concise. 0.76. What is the ratio of the Claims (% of GDP) of Maldives in 2009 to that in 2012?
Provide a short and direct response. 1.42. What is the ratio of the Claims (% of GDP) in Small states in 2010 to that in 2011?
Provide a short and direct response. 1.06. What is the ratio of the Claims (% of GDP) of Burundi in 2010 to that in 2011?
Your response must be concise. 0.9. What is the ratio of the Claims (% of GDP) of Haiti in 2010 to that in 2011?
Provide a short and direct response. 0.91. What is the ratio of the Claims (% of GDP) of Maldives in 2010 to that in 2011?
Make the answer very short. 1.1. What is the ratio of the Claims (% of GDP) of Small states in 2010 to that in 2012?
Give a very brief answer. 1.02. What is the ratio of the Claims (% of GDP) of Burundi in 2010 to that in 2012?
Ensure brevity in your answer.  0.96. What is the ratio of the Claims (% of GDP) of Haiti in 2010 to that in 2012?
Provide a succinct answer. 0.76. What is the ratio of the Claims (% of GDP) of Maldives in 2010 to that in 2012?
Provide a short and direct response. 1.31. What is the ratio of the Claims (% of GDP) of Small states in 2011 to that in 2012?
Your response must be concise. 0.96. What is the ratio of the Claims (% of GDP) in Burundi in 2011 to that in 2012?
Keep it short and to the point. 1.06. What is the ratio of the Claims (% of GDP) of Haiti in 2011 to that in 2012?
Give a very brief answer. 0.83. What is the ratio of the Claims (% of GDP) of Maldives in 2011 to that in 2012?
Your answer should be very brief. 1.19. What is the difference between the highest and the second highest Claims (% of GDP) of Small states?
Your response must be concise. 3.9. What is the difference between the highest and the second highest Claims (% of GDP) of Burundi?
Ensure brevity in your answer.  1.04. What is the difference between the highest and the second highest Claims (% of GDP) of Haiti?
Ensure brevity in your answer.  3.82. What is the difference between the highest and the second highest Claims (% of GDP) of Maldives?
Ensure brevity in your answer.  3.74. What is the difference between the highest and the lowest Claims (% of GDP) in Small states?
Your response must be concise. 6.04. What is the difference between the highest and the lowest Claims (% of GDP) of Burundi?
Your response must be concise. 4.22. What is the difference between the highest and the lowest Claims (% of GDP) in Haiti?
Keep it short and to the point. 7.69. What is the difference between the highest and the lowest Claims (% of GDP) of Maldives?
Give a very brief answer. 22.55. 